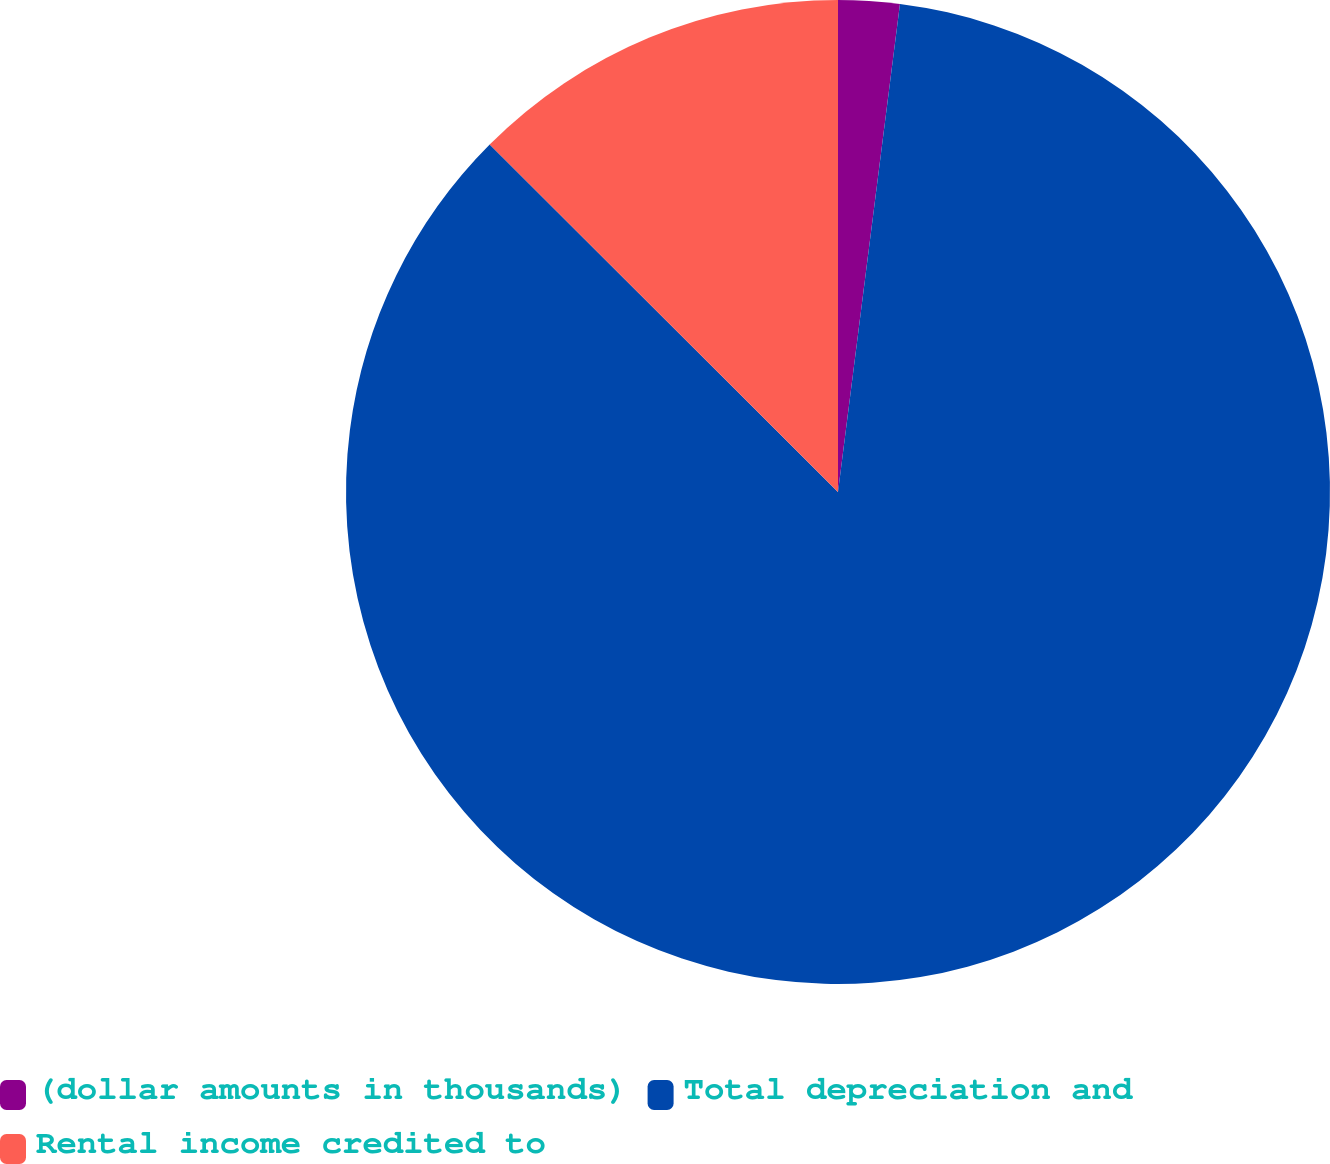Convert chart. <chart><loc_0><loc_0><loc_500><loc_500><pie_chart><fcel>(dollar amounts in thousands)<fcel>Total depreciation and<fcel>Rental income credited to<nl><fcel>2.01%<fcel>85.48%<fcel>12.52%<nl></chart> 